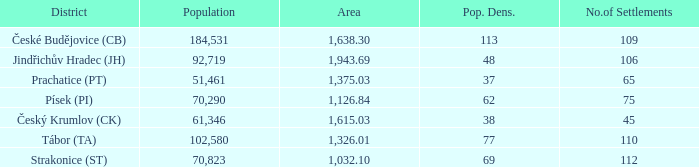How many settlements are in český krumlov (ck) with a population density higher than 38? None. Give me the full table as a dictionary. {'header': ['District', 'Population', 'Area', 'Pop. Dens.', 'No.of Settlements'], 'rows': [['České Budějovice (CB)', '184,531', '1,638.30', '113', '109'], ['Jindřichův Hradec (JH)', '92,719', '1,943.69', '48', '106'], ['Prachatice (PT)', '51,461', '1,375.03', '37', '65'], ['Písek (PI)', '70,290', '1,126.84', '62', '75'], ['Český Krumlov (CK)', '61,346', '1,615.03', '38', '45'], ['Tábor (TA)', '102,580', '1,326.01', '77', '110'], ['Strakonice (ST)', '70,823', '1,032.10', '69', '112']]} 